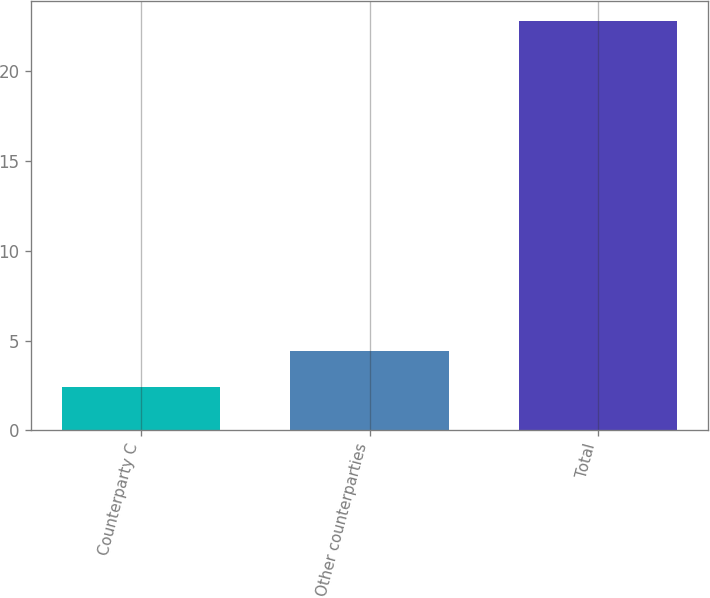<chart> <loc_0><loc_0><loc_500><loc_500><bar_chart><fcel>Counterparty C<fcel>Other counterparties<fcel>Total<nl><fcel>2.4<fcel>4.44<fcel>22.8<nl></chart> 